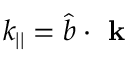Convert formula to latex. <formula><loc_0><loc_0><loc_500><loc_500>k _ { | | } = \hat { b } \cdot k</formula> 